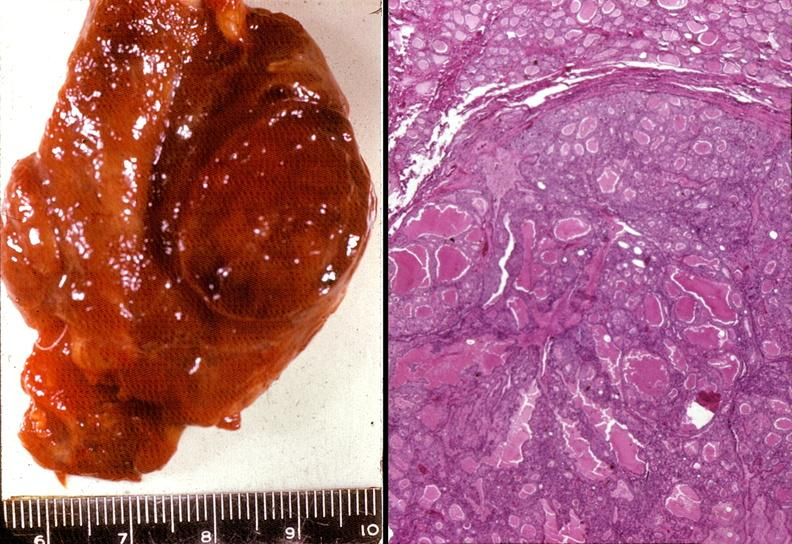what does this image show?
Answer the question using a single word or phrase. Thyroid 